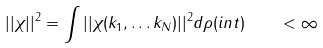Convert formula to latex. <formula><loc_0><loc_0><loc_500><loc_500>| | \chi | | ^ { 2 } = \int \nolimits | | \chi ( { k } _ { 1 } , \dots { k } _ { N } ) | | ^ { 2 } d \rho ( i n t ) \quad < \infty</formula> 